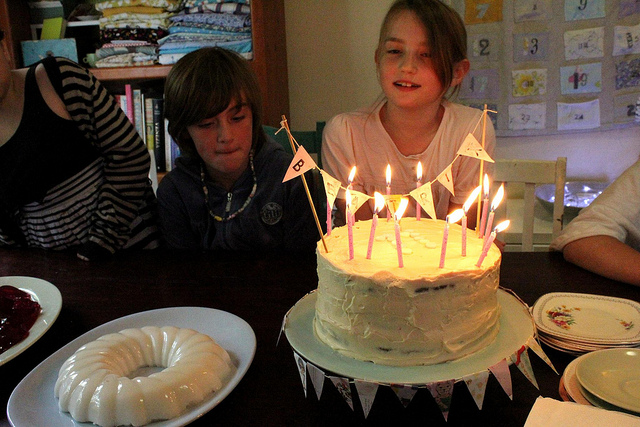Can you describe the cake in the image? The cake has multiple layers, appears to be frosted with a creamy white icing, and is adorned with small colorful candles and a festive banner. It gives the impression of a homemade birthday cake. 